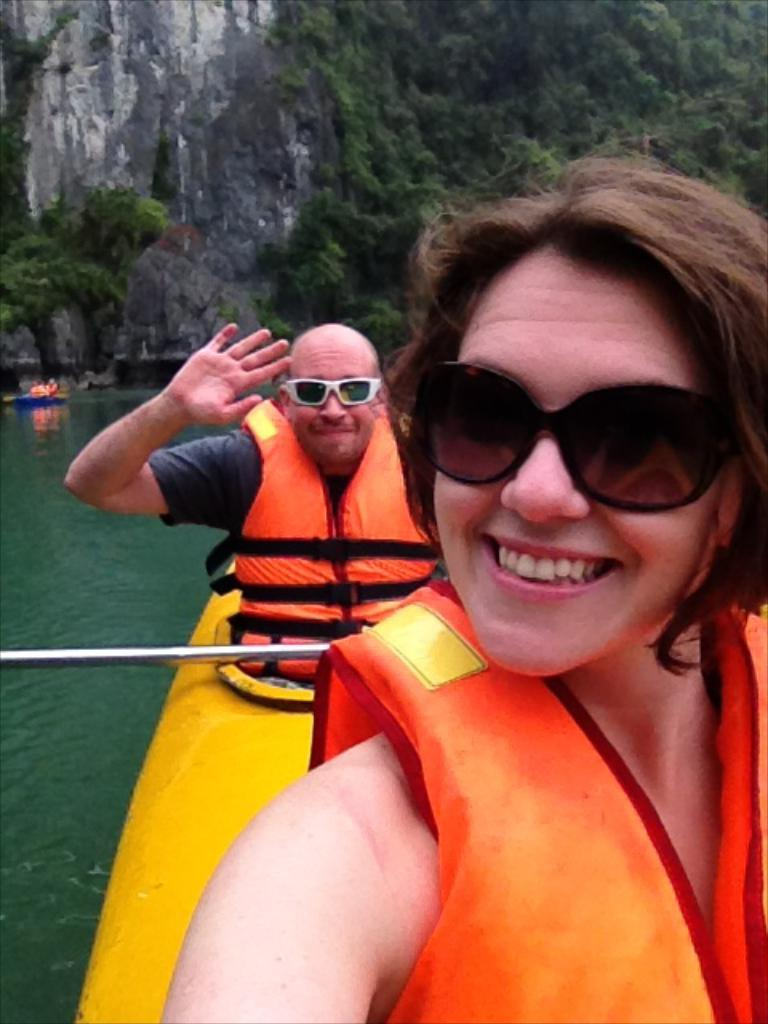What is happening on the water in the image? There are boats on the water in the image, and people are sitting on the boats. What are the people holding while on the boats? The people are holding iron rods. What can be seen in the background of the image? There are trees and rocks visible in the image. How many oranges are being crushed by the worm in the image? There are no oranges or worms present in the image. What type of worm can be seen crawling on the rocks in the image? There are no worms visible in the image; only boats, people, trees, and rocks can be seen. 